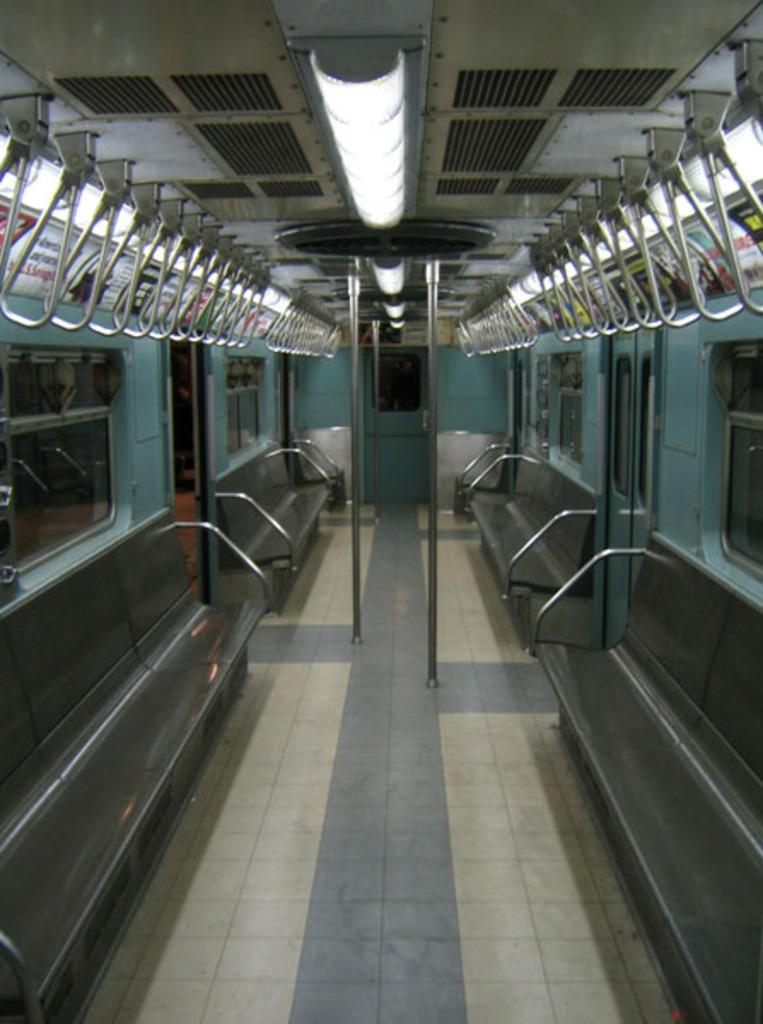What type of seating is visible in the image? There are benches in the image. What can be seen illuminating the area in the image? There are lights in the image. What structures are supporting the lights in the image? There are poles in the image. What architectural features are visible in the image? There are windows in the image. What mode of transportation is the image depicting? The image is an inside view of a train. What type of corn is being served in the image? There is no corn present in the image; it is an inside view of a train with benches, lights, poles, and windows. How much does the box weigh in the image? There is no box present in the image. 